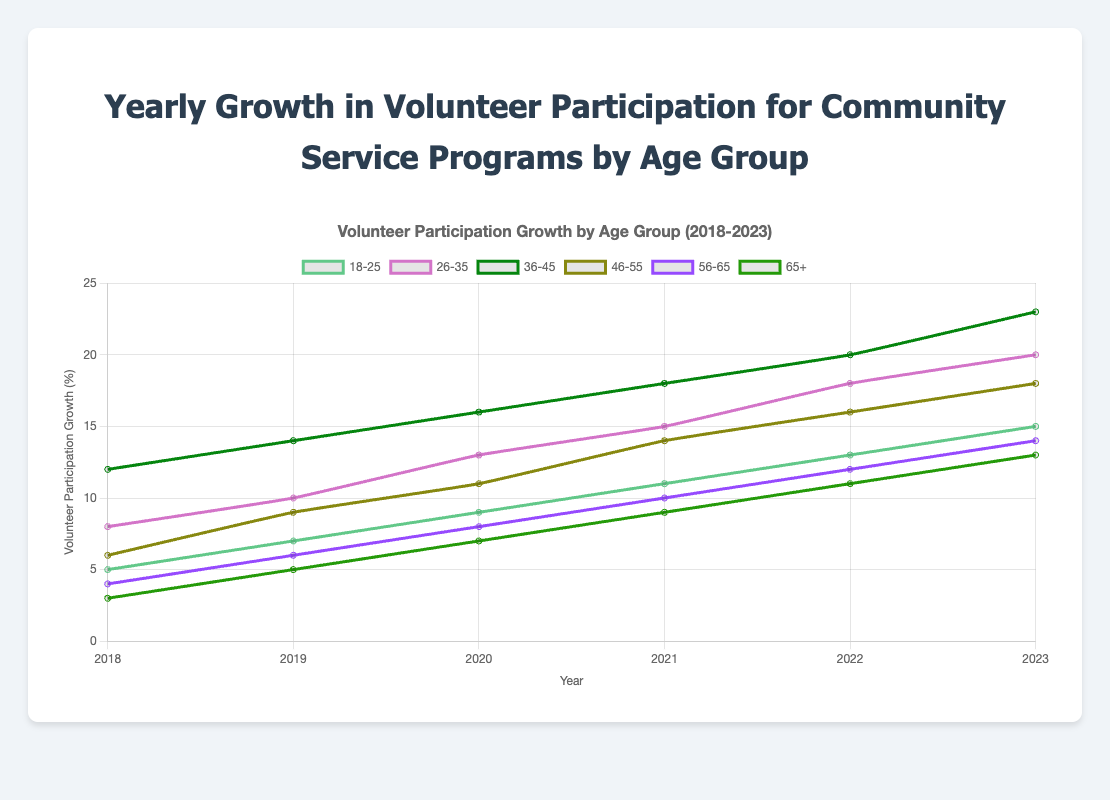What is the average yearly growth rate for the 18-25 age group from 2018 to 2023? Sum the growth rates for the years 2018 (5), 2019 (7), 2020 (9), 2021 (11), 2022 (13), 2023 (15) and then divide by the number of years (6). (5+7+9+11+13+15) / 6 = 10
Answer: 10 Which age group had the highest participation growth in 2023? Refer to the data for 2023 and identify the age group with the highest value: 18-25 (15), 26-35 (20), 36-45 (23), 46-55 (18), 56-65 (14), 65+ (13). The highest value is 23 for the age group 36-45
Answer: 36-45 Did the 46-55 age group's participation growth rate increase every year from 2018 to 2023? Check the values sequentially for the 46-55 age group over the years: 2018 (6), 2019 (9), 2020 (11), 2021 (14), 2022 (16), 2023 (18). Each year the value is increasing.
Answer: Yes What is the total growth in volunteer participation from 2018 to 2023 for the 56-65 age group? Sum the growth rates for the 56-65 age group over the years: 2018 (4), 2019 (6), 2020 (8), 2021 (10), 2022 (12), 2023 (14). The total is 4+6+8+10+12+14 = 54
Answer: 54 Which two consecutive years had the highest increase in volunteer participation for the 26-35 age group? Calculate the differences between consecutive years: 2018 (8) to 2019 (10) = 2, 2019 to 2020 (13) = 3, 2020 to 2021 (15) = 2, 2021 to 2022 (18) = 3, 2022 to 2023 (20) = 2. The highest increase is between 2019 and 2020 and 2021 and 2022, both with increases of 3.
Answer: 2019-2020 and 2021-2022 In which year did the 65+ age group first reach a growth rate of 9 or above? Look through the data for the 65+ age group: 2018 (3), 2019 (5), 2020 (7), 2021 (9), 2022 (11), 2023 (13). The first occurrence of a value 9 or above is in 2021.
Answer: 2021 How many age groups had a growth rate of 10 or more in 2021? Check the data for each age group in 2021: 18-25 (11), 26-35 (15), 36-45 (18), 46-55 (14), 56-65 (10), 65+ (9). Count the number of age groups with values 10 or more. There are 5 groups: 18-25, 26-35, 36-45, 46-55, 56-65.
Answer: 5 What is the difference in growth rates between the 18-25 and 65+ age groups in 2022? Subtract the growth rate of the 65+ age group from that of the 18-25 age group in 2022: 18-25 (13), 65+ (11). The difference is 13 - 11 = 2.
Answer: 2 What is the minimum growth rate observed across all age groups in any year from 2018 to 2023? Look through the data for each year and each age group to find the minimum value: 2018 (3), 2019 (5), 2020 (7), 2021 (9), 2022 (11), 2023 (13). The minimum value observed is 3 in the 65+ age group in 2018.
Answer: 3 